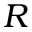<formula> <loc_0><loc_0><loc_500><loc_500>R</formula> 